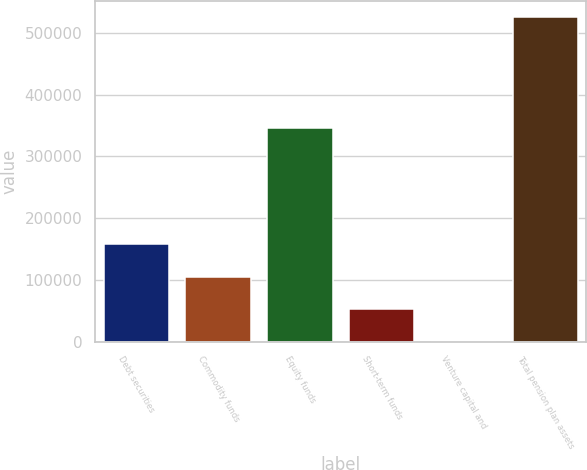Convert chart to OTSL. <chart><loc_0><loc_0><loc_500><loc_500><bar_chart><fcel>Debt securities<fcel>Commodity funds<fcel>Equity funds<fcel>Short-term funds<fcel>Venture capital and<fcel>Total pension plan assets<nl><fcel>157613<fcel>105076<fcel>346632<fcel>52539.6<fcel>2.88<fcel>525370<nl></chart> 